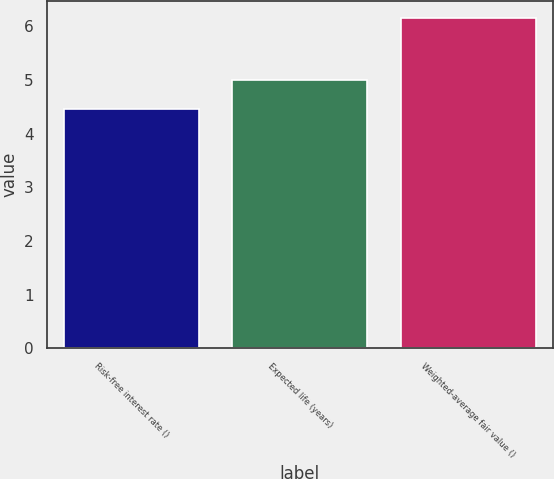<chart> <loc_0><loc_0><loc_500><loc_500><bar_chart><fcel>Risk-free interest rate ()<fcel>Expected life (years)<fcel>Weighted-average fair value ()<nl><fcel>4.45<fcel>5<fcel>6.16<nl></chart> 